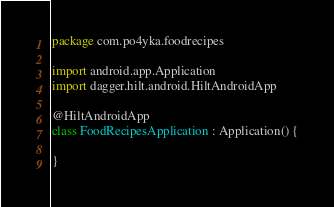<code> <loc_0><loc_0><loc_500><loc_500><_Kotlin_>package com.po4yka.foodrecipes

import android.app.Application
import dagger.hilt.android.HiltAndroidApp

@HiltAndroidApp
class FoodRecipesApplication : Application() {

}</code> 